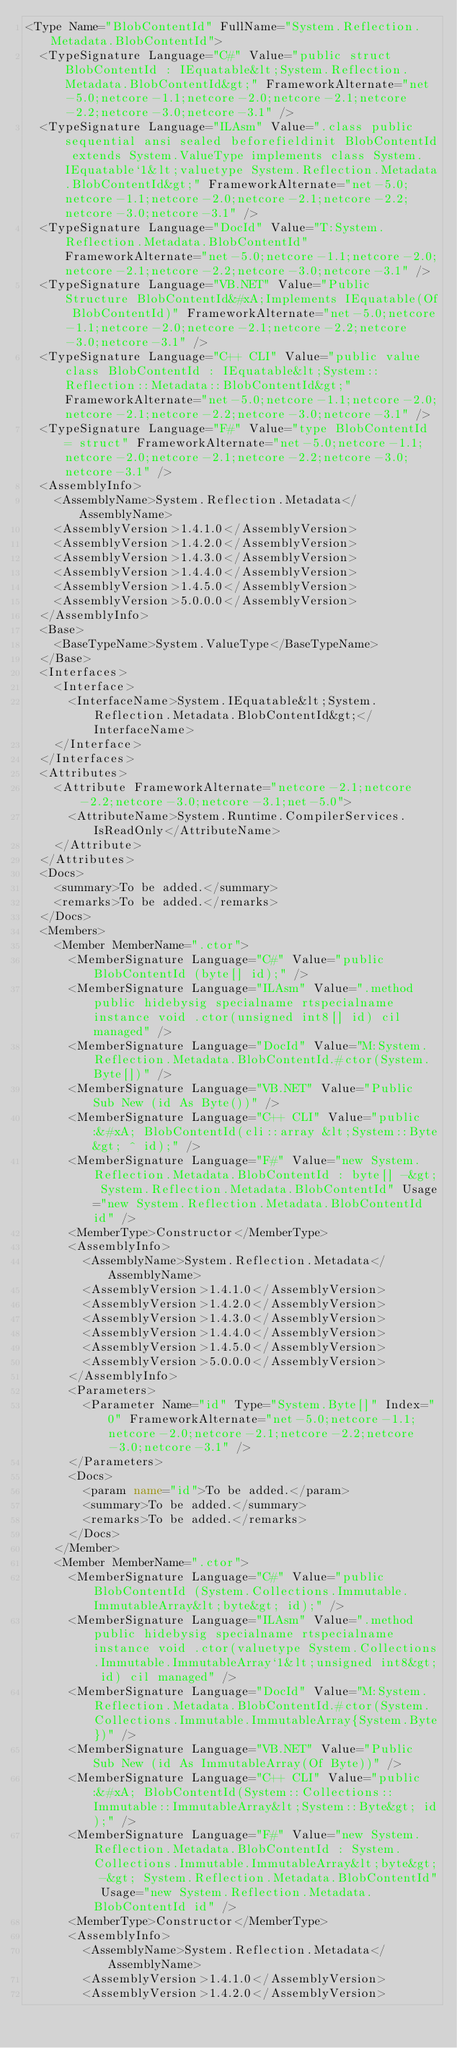Convert code to text. <code><loc_0><loc_0><loc_500><loc_500><_XML_><Type Name="BlobContentId" FullName="System.Reflection.Metadata.BlobContentId">
  <TypeSignature Language="C#" Value="public struct BlobContentId : IEquatable&lt;System.Reflection.Metadata.BlobContentId&gt;" FrameworkAlternate="net-5.0;netcore-1.1;netcore-2.0;netcore-2.1;netcore-2.2;netcore-3.0;netcore-3.1" />
  <TypeSignature Language="ILAsm" Value=".class public sequential ansi sealed beforefieldinit BlobContentId extends System.ValueType implements class System.IEquatable`1&lt;valuetype System.Reflection.Metadata.BlobContentId&gt;" FrameworkAlternate="net-5.0;netcore-1.1;netcore-2.0;netcore-2.1;netcore-2.2;netcore-3.0;netcore-3.1" />
  <TypeSignature Language="DocId" Value="T:System.Reflection.Metadata.BlobContentId" FrameworkAlternate="net-5.0;netcore-1.1;netcore-2.0;netcore-2.1;netcore-2.2;netcore-3.0;netcore-3.1" />
  <TypeSignature Language="VB.NET" Value="Public Structure BlobContentId&#xA;Implements IEquatable(Of BlobContentId)" FrameworkAlternate="net-5.0;netcore-1.1;netcore-2.0;netcore-2.1;netcore-2.2;netcore-3.0;netcore-3.1" />
  <TypeSignature Language="C++ CLI" Value="public value class BlobContentId : IEquatable&lt;System::Reflection::Metadata::BlobContentId&gt;" FrameworkAlternate="net-5.0;netcore-1.1;netcore-2.0;netcore-2.1;netcore-2.2;netcore-3.0;netcore-3.1" />
  <TypeSignature Language="F#" Value="type BlobContentId = struct" FrameworkAlternate="net-5.0;netcore-1.1;netcore-2.0;netcore-2.1;netcore-2.2;netcore-3.0;netcore-3.1" />
  <AssemblyInfo>
    <AssemblyName>System.Reflection.Metadata</AssemblyName>
    <AssemblyVersion>1.4.1.0</AssemblyVersion>
    <AssemblyVersion>1.4.2.0</AssemblyVersion>
    <AssemblyVersion>1.4.3.0</AssemblyVersion>
    <AssemblyVersion>1.4.4.0</AssemblyVersion>
    <AssemblyVersion>1.4.5.0</AssemblyVersion>
    <AssemblyVersion>5.0.0.0</AssemblyVersion>
  </AssemblyInfo>
  <Base>
    <BaseTypeName>System.ValueType</BaseTypeName>
  </Base>
  <Interfaces>
    <Interface>
      <InterfaceName>System.IEquatable&lt;System.Reflection.Metadata.BlobContentId&gt;</InterfaceName>
    </Interface>
  </Interfaces>
  <Attributes>
    <Attribute FrameworkAlternate="netcore-2.1;netcore-2.2;netcore-3.0;netcore-3.1;net-5.0">
      <AttributeName>System.Runtime.CompilerServices.IsReadOnly</AttributeName>
    </Attribute>
  </Attributes>
  <Docs>
    <summary>To be added.</summary>
    <remarks>To be added.</remarks>
  </Docs>
  <Members>
    <Member MemberName=".ctor">
      <MemberSignature Language="C#" Value="public BlobContentId (byte[] id);" />
      <MemberSignature Language="ILAsm" Value=".method public hidebysig specialname rtspecialname instance void .ctor(unsigned int8[] id) cil managed" />
      <MemberSignature Language="DocId" Value="M:System.Reflection.Metadata.BlobContentId.#ctor(System.Byte[])" />
      <MemberSignature Language="VB.NET" Value="Public Sub New (id As Byte())" />
      <MemberSignature Language="C++ CLI" Value="public:&#xA; BlobContentId(cli::array &lt;System::Byte&gt; ^ id);" />
      <MemberSignature Language="F#" Value="new System.Reflection.Metadata.BlobContentId : byte[] -&gt; System.Reflection.Metadata.BlobContentId" Usage="new System.Reflection.Metadata.BlobContentId id" />
      <MemberType>Constructor</MemberType>
      <AssemblyInfo>
        <AssemblyName>System.Reflection.Metadata</AssemblyName>
        <AssemblyVersion>1.4.1.0</AssemblyVersion>
        <AssemblyVersion>1.4.2.0</AssemblyVersion>
        <AssemblyVersion>1.4.3.0</AssemblyVersion>
        <AssemblyVersion>1.4.4.0</AssemblyVersion>
        <AssemblyVersion>1.4.5.0</AssemblyVersion>
        <AssemblyVersion>5.0.0.0</AssemblyVersion>
      </AssemblyInfo>
      <Parameters>
        <Parameter Name="id" Type="System.Byte[]" Index="0" FrameworkAlternate="net-5.0;netcore-1.1;netcore-2.0;netcore-2.1;netcore-2.2;netcore-3.0;netcore-3.1" />
      </Parameters>
      <Docs>
        <param name="id">To be added.</param>
        <summary>To be added.</summary>
        <remarks>To be added.</remarks>
      </Docs>
    </Member>
    <Member MemberName=".ctor">
      <MemberSignature Language="C#" Value="public BlobContentId (System.Collections.Immutable.ImmutableArray&lt;byte&gt; id);" />
      <MemberSignature Language="ILAsm" Value=".method public hidebysig specialname rtspecialname instance void .ctor(valuetype System.Collections.Immutable.ImmutableArray`1&lt;unsigned int8&gt; id) cil managed" />
      <MemberSignature Language="DocId" Value="M:System.Reflection.Metadata.BlobContentId.#ctor(System.Collections.Immutable.ImmutableArray{System.Byte})" />
      <MemberSignature Language="VB.NET" Value="Public Sub New (id As ImmutableArray(Of Byte))" />
      <MemberSignature Language="C++ CLI" Value="public:&#xA; BlobContentId(System::Collections::Immutable::ImmutableArray&lt;System::Byte&gt; id);" />
      <MemberSignature Language="F#" Value="new System.Reflection.Metadata.BlobContentId : System.Collections.Immutable.ImmutableArray&lt;byte&gt; -&gt; System.Reflection.Metadata.BlobContentId" Usage="new System.Reflection.Metadata.BlobContentId id" />
      <MemberType>Constructor</MemberType>
      <AssemblyInfo>
        <AssemblyName>System.Reflection.Metadata</AssemblyName>
        <AssemblyVersion>1.4.1.0</AssemblyVersion>
        <AssemblyVersion>1.4.2.0</AssemblyVersion></code> 